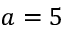<formula> <loc_0><loc_0><loc_500><loc_500>a = 5</formula> 